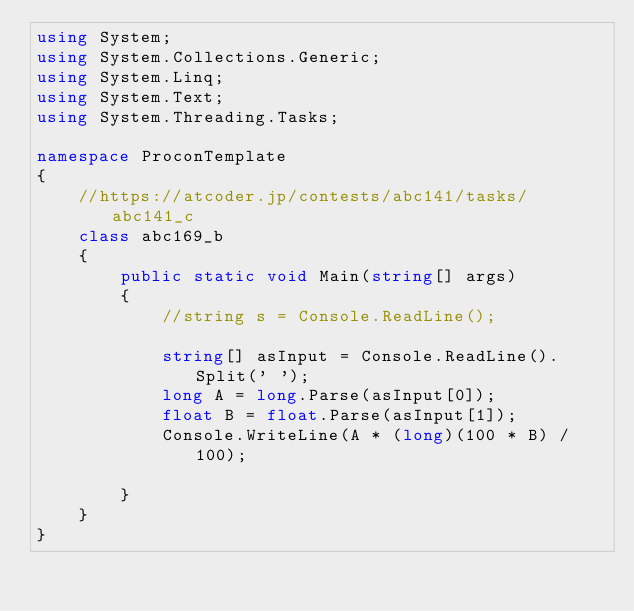<code> <loc_0><loc_0><loc_500><loc_500><_C#_>using System;
using System.Collections.Generic;
using System.Linq;
using System.Text;
using System.Threading.Tasks;

namespace ProconTemplate
{
    //https://atcoder.jp/contests/abc141/tasks/abc141_c
    class abc169_b
    {
        public static void Main(string[] args)
        {
            //string s = Console.ReadLine();

            string[] asInput = Console.ReadLine().Split(' ');
            long A = long.Parse(asInput[0]);
            float B = float.Parse(asInput[1]);
            Console.WriteLine(A * (long)(100 * B) / 100);

        }
    }
}
</code> 